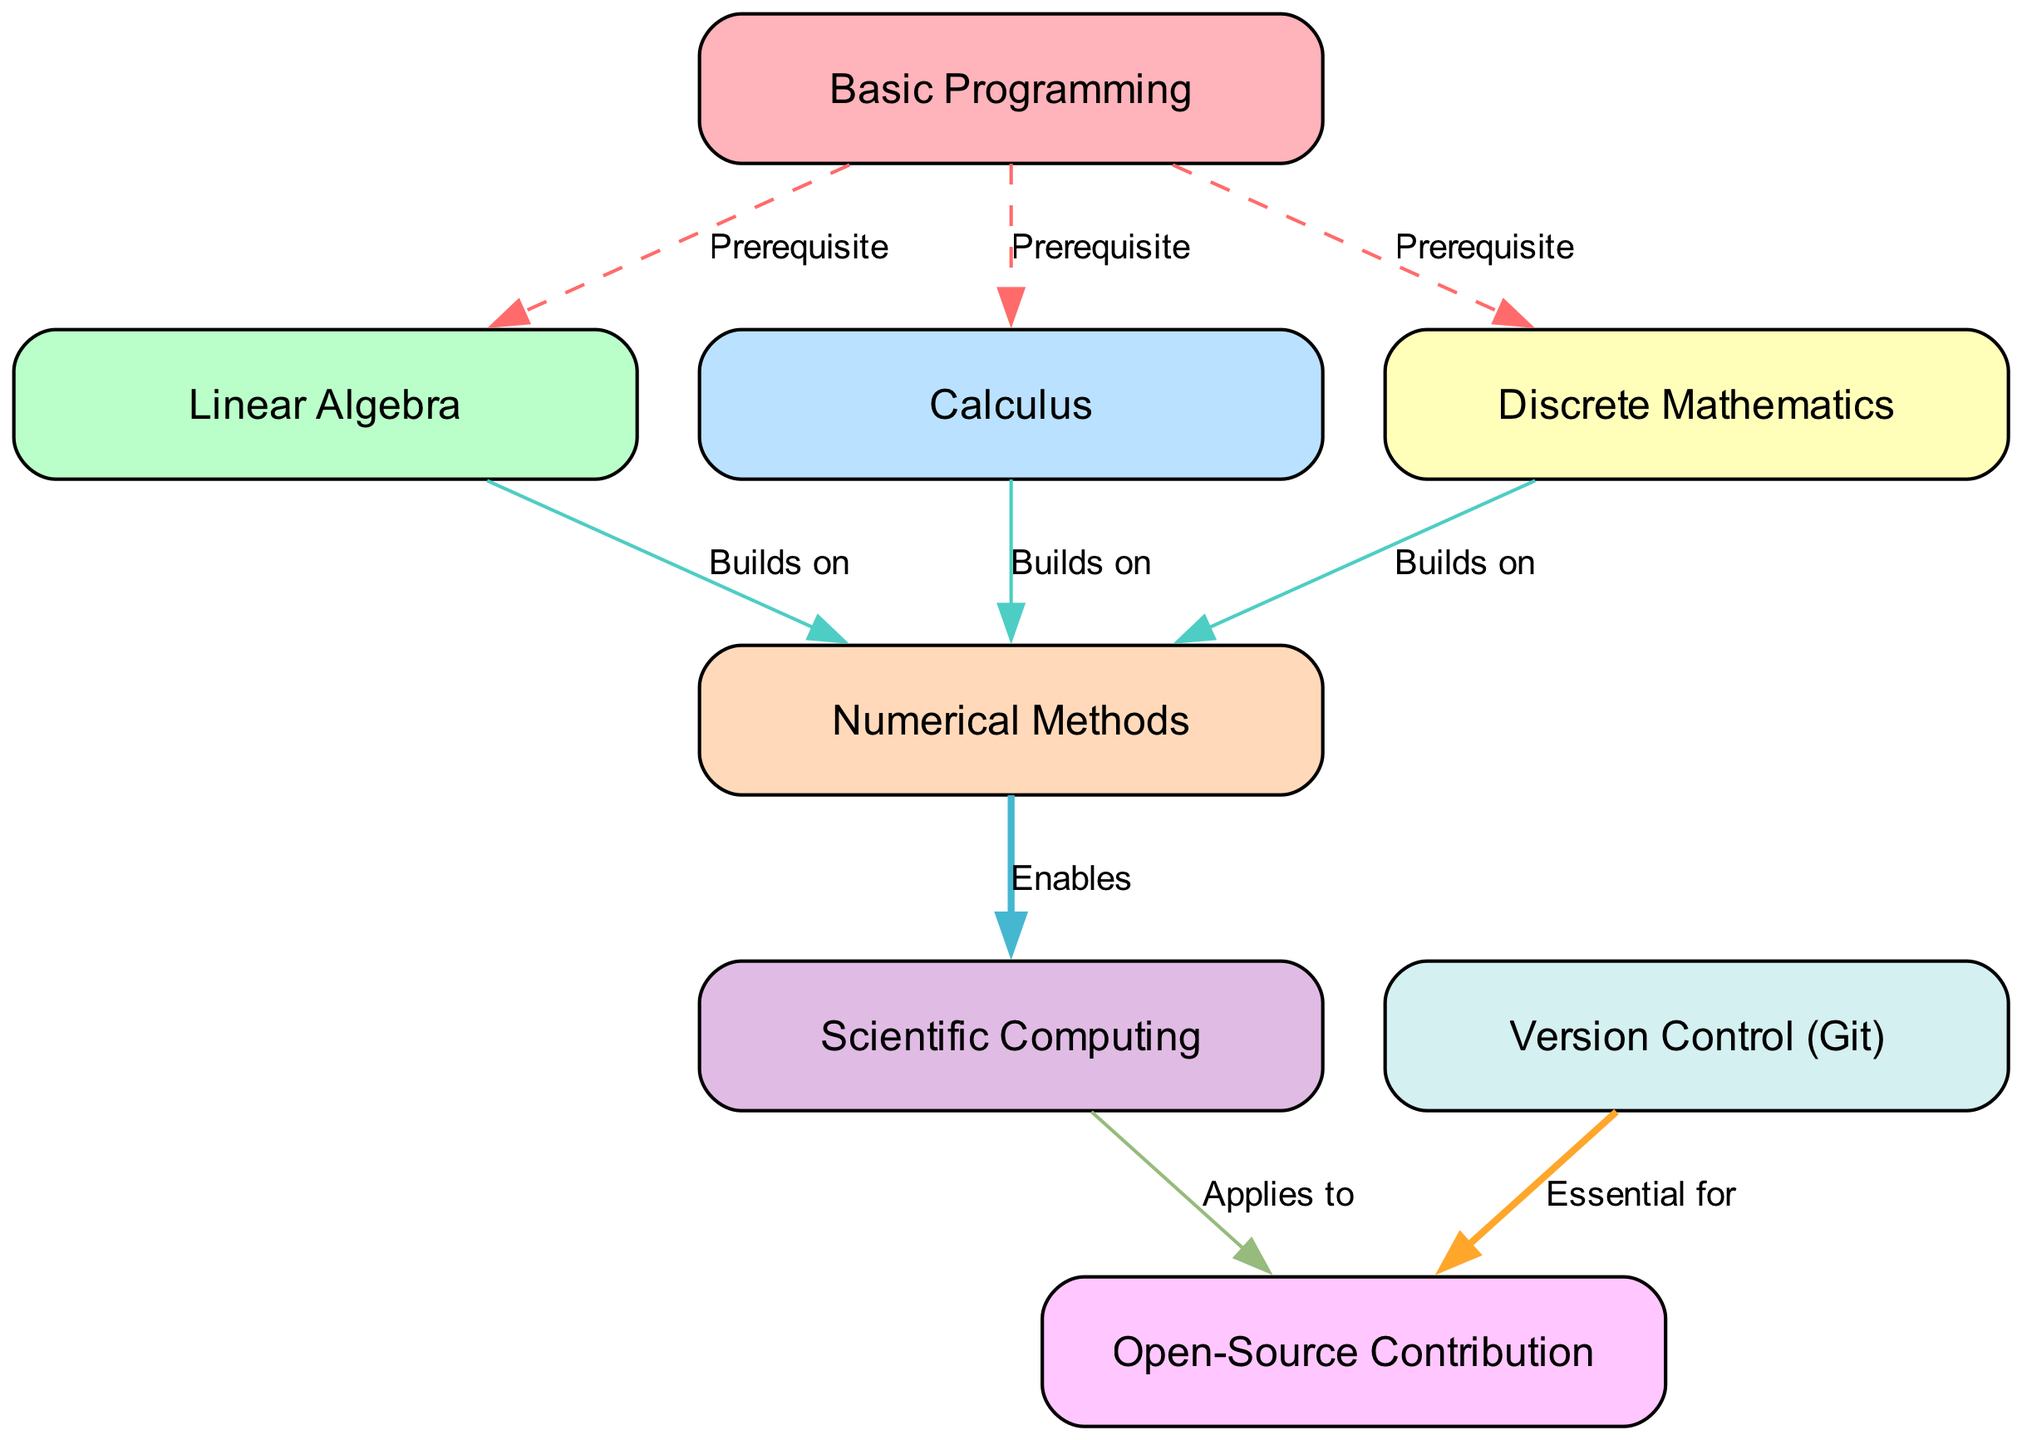What is the total number of nodes in the diagram? The diagram contains nodes representing key mathematical concepts and skills needed for open-source contributions. Counting from the provided data, there are eight unique nodes listed.
Answer: Eight Which concept needs to be mastered before learning Scientific Computing? The directed edge indicates prerequisites among the nodes. From the diagram, Numerical Methods is the only node that connects to Scientific Computing, indicating it must be learned first.
Answer: Numerical Methods What relationship exists between Linear Algebra and Numerical Methods? The diagram shows a directed edge from Linear Algebra to Numerical Methods labeled "Builds on." This signifies that knowledge of Linear Algebra is important for understanding Numerical Methods.
Answer: Builds on How many edges are depicted in the diagram? The diagram features directed relationships between the nodes, denoting the pathways of knowledge. The provided data highlights eight connections, making that the total edge count displayed.
Answer: Eight Which two concepts are essential prerequisites before beginning Open-Source Contribution? The directed graph shows that both Scientific Computing and Version Control (Git) are necessary before contributing to open source. Each has its own edge leading to Open-Source Contribution labeled "Applies to" and "Essential for," respectively.
Answer: Scientific Computing and Version Control (Git) What prerequisite must be fulfilled to move on to Numerical Methods? The diagram indicates that all three prior concepts—Linear Algebra, Calculus, and Discrete Mathematics—are required before one can move on to Numerical Methods. This can be seen directly from the edges connecting these nodes.
Answer: Linear Algebra, Calculus, and Discrete Mathematics What are the main subjects required prior to learning Discrete Mathematics? The diagram shows that only Basic Programming is a prerequisite for learning Discrete Mathematics, represented by a direct edge leading to it.
Answer: Basic Programming Which mathematical concept serves as a foundational part for both Linear Algebra and Calculus? According to the diagram, Basic Programming serves as the starting point that leads to both Linear Algebra and Calculus, as indicated by the outgoing edges from Basic Programming.
Answer: Basic Programming 